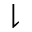Convert formula to latex. <formula><loc_0><loc_0><loc_500><loc_500>\downharpoonright</formula> 